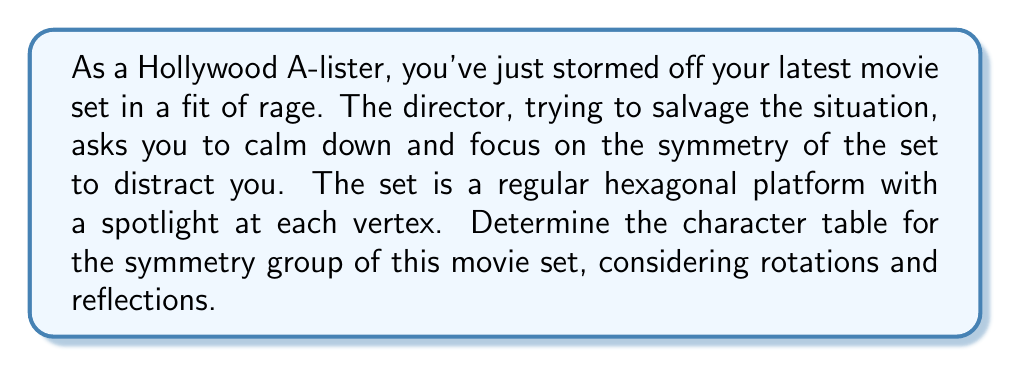Teach me how to tackle this problem. Let's approach this step-by-step:

1) First, we need to identify the symmetry group. The symmetry group of a regular hexagon is the dihedral group $D_6$, which has 12 elements.

2) The conjugacy classes of $D_6$ are:
   - $e$ (identity)
   - $r, r^5$ (rotations by 60° and 300°)
   - $r^2, r^4$ (rotations by 120° and 240°)
   - $r^3$ (rotation by 180°)
   - $s, sr, sr^2, sr^3, sr^4, sr^5$ (6 reflections)

3) $D_6$ has 6 irreducible representations: 4 one-dimensional and 2 two-dimensional.

4) The character table will be a 6x6 matrix. Let's label the rows as $\chi_1, \chi_2, \chi_3, \chi_4, \chi_5, \chi_6$ and the columns as $\{e\}, \{r, r^5\}, \{r^2, r^4\}, \{r^3\}, \{s, sr^2, sr^4\}, \{sr, sr^3, sr^5\}$.

5) We know that:
   - $\chi_1$ is the trivial representation (all 1's)
   - $\chi_2(g) = 1$ for rotations, $-1$ for reflections
   - $\chi_3(g) = 1$ for even rotations and reflections through vertices, $-1$ otherwise
   - $\chi_4(g) = 1$ for even rotations and reflections through edges, $-1$ otherwise
   - $\chi_5$ and $\chi_6$ are two-dimensional representations

6) For $\chi_5$ and $\chi_6$, we use the formula $\chi(r^k) = 2\cos(2\pi k/6)$ for rotations and $\chi(s) = 0$ for reflections.

7) Putting it all together, we get the character table:

$$
\begin{array}{c|cccccc}
D_6 & \{e\} & \{r, r^5\} & \{r^2, r^4\} & \{r^3\} & \{s, sr^2, sr^4\} & \{sr, sr^3, sr^5\} \\
\hline
\chi_1 & 1 & 1 & 1 & 1 & 1 & 1 \\
\chi_2 & 1 & 1 & 1 & 1 & -1 & -1 \\
\chi_3 & 1 & -1 & 1 & -1 & 1 & -1 \\
\chi_4 & 1 & -1 & 1 & -1 & -1 & 1 \\
\chi_5 & 2 & 1 & -1 & -2 & 0 & 0 \\
\chi_6 & 2 & -1 & -1 & 2 & 0 & 0
\end{array}
$$
Answer: $$
\begin{array}{c|cccccc}
D_6 & \{e\} & \{r, r^5\} & \{r^2, r^4\} & \{r^3\} & \{s, sr^2, sr^4\} & \{sr, sr^3, sr^5\} \\
\hline
\chi_1 & 1 & 1 & 1 & 1 & 1 & 1 \\
\chi_2 & 1 & 1 & 1 & 1 & -1 & -1 \\
\chi_3 & 1 & -1 & 1 & -1 & 1 & -1 \\
\chi_4 & 1 & -1 & 1 & -1 & -1 & 1 \\
\chi_5 & 2 & 1 & -1 & -2 & 0 & 0 \\
\chi_6 & 2 & -1 & -1 & 2 & 0 & 0
\end{array}
$$ 